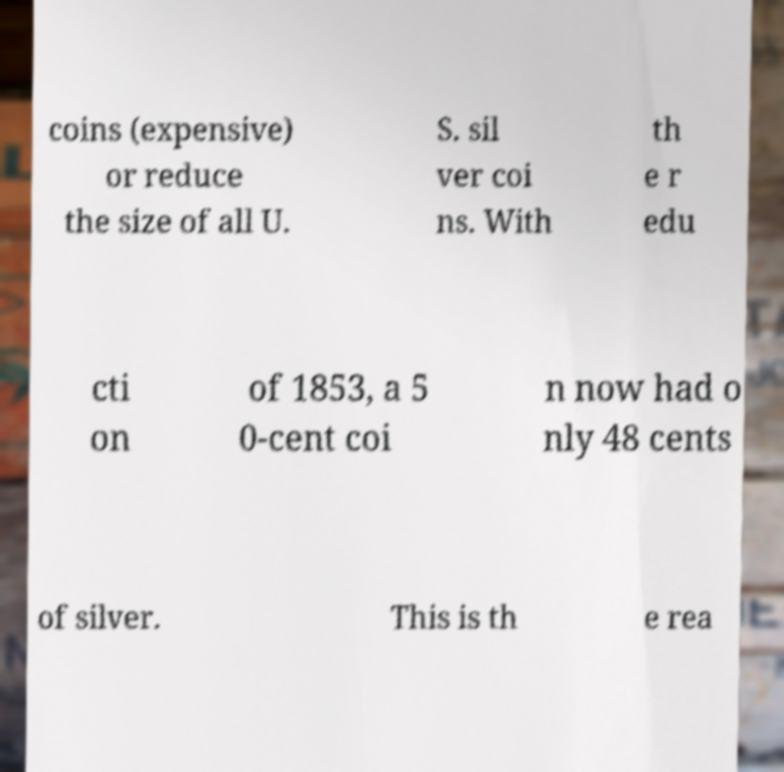Could you extract and type out the text from this image? coins (expensive) or reduce the size of all U. S. sil ver coi ns. With th e r edu cti on of 1853, a 5 0-cent coi n now had o nly 48 cents of silver. This is th e rea 